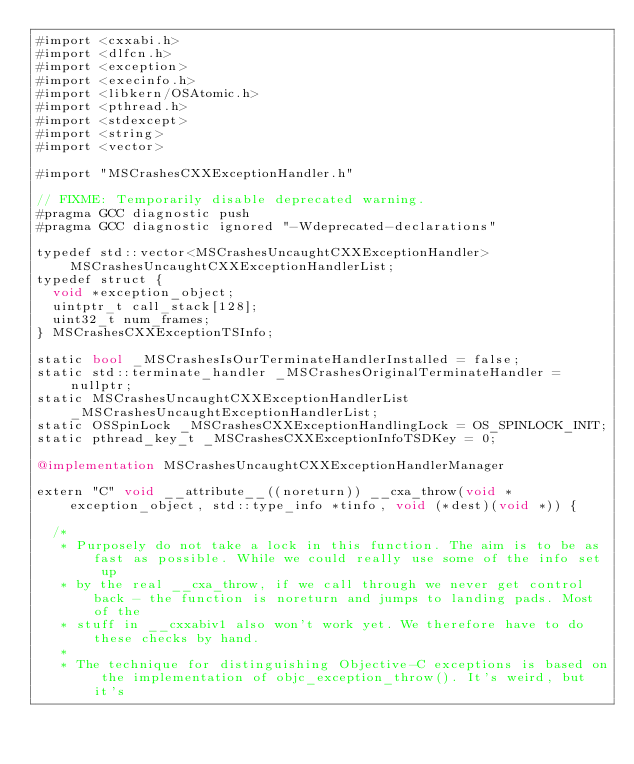<code> <loc_0><loc_0><loc_500><loc_500><_ObjectiveC_>#import <cxxabi.h>
#import <dlfcn.h>
#import <exception>
#import <execinfo.h>
#import <libkern/OSAtomic.h>
#import <pthread.h>
#import <stdexcept>
#import <string>
#import <vector>

#import "MSCrashesCXXExceptionHandler.h"

// FIXME: Temporarily disable deprecated warning.
#pragma GCC diagnostic push
#pragma GCC diagnostic ignored "-Wdeprecated-declarations"

typedef std::vector<MSCrashesUncaughtCXXExceptionHandler> MSCrashesUncaughtCXXExceptionHandlerList;
typedef struct {
  void *exception_object;
  uintptr_t call_stack[128];
  uint32_t num_frames;
} MSCrashesCXXExceptionTSInfo;

static bool _MSCrashesIsOurTerminateHandlerInstalled = false;
static std::terminate_handler _MSCrashesOriginalTerminateHandler = nullptr;
static MSCrashesUncaughtCXXExceptionHandlerList _MSCrashesUncaughtExceptionHandlerList;
static OSSpinLock _MSCrashesCXXExceptionHandlingLock = OS_SPINLOCK_INIT;
static pthread_key_t _MSCrashesCXXExceptionInfoTSDKey = 0;

@implementation MSCrashesUncaughtCXXExceptionHandlerManager

extern "C" void __attribute__((noreturn)) __cxa_throw(void *exception_object, std::type_info *tinfo, void (*dest)(void *)) {

  /*
   * Purposely do not take a lock in this function. The aim is to be as fast as possible. While we could really use some of the info set up
   * by the real __cxa_throw, if we call through we never get control back - the function is noreturn and jumps to landing pads. Most of the
   * stuff in __cxxabiv1 also won't work yet. We therefore have to do these checks by hand.
   *
   * The technique for distinguishing Objective-C exceptions is based on the implementation of objc_exception_throw(). It's weird, but it's</code> 